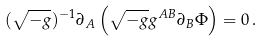Convert formula to latex. <formula><loc_0><loc_0><loc_500><loc_500>( \sqrt { - g } ) ^ { - 1 } \partial _ { A } \left ( \sqrt { - g } g ^ { A B } \partial _ { B } \Phi \right ) = 0 \, .</formula> 